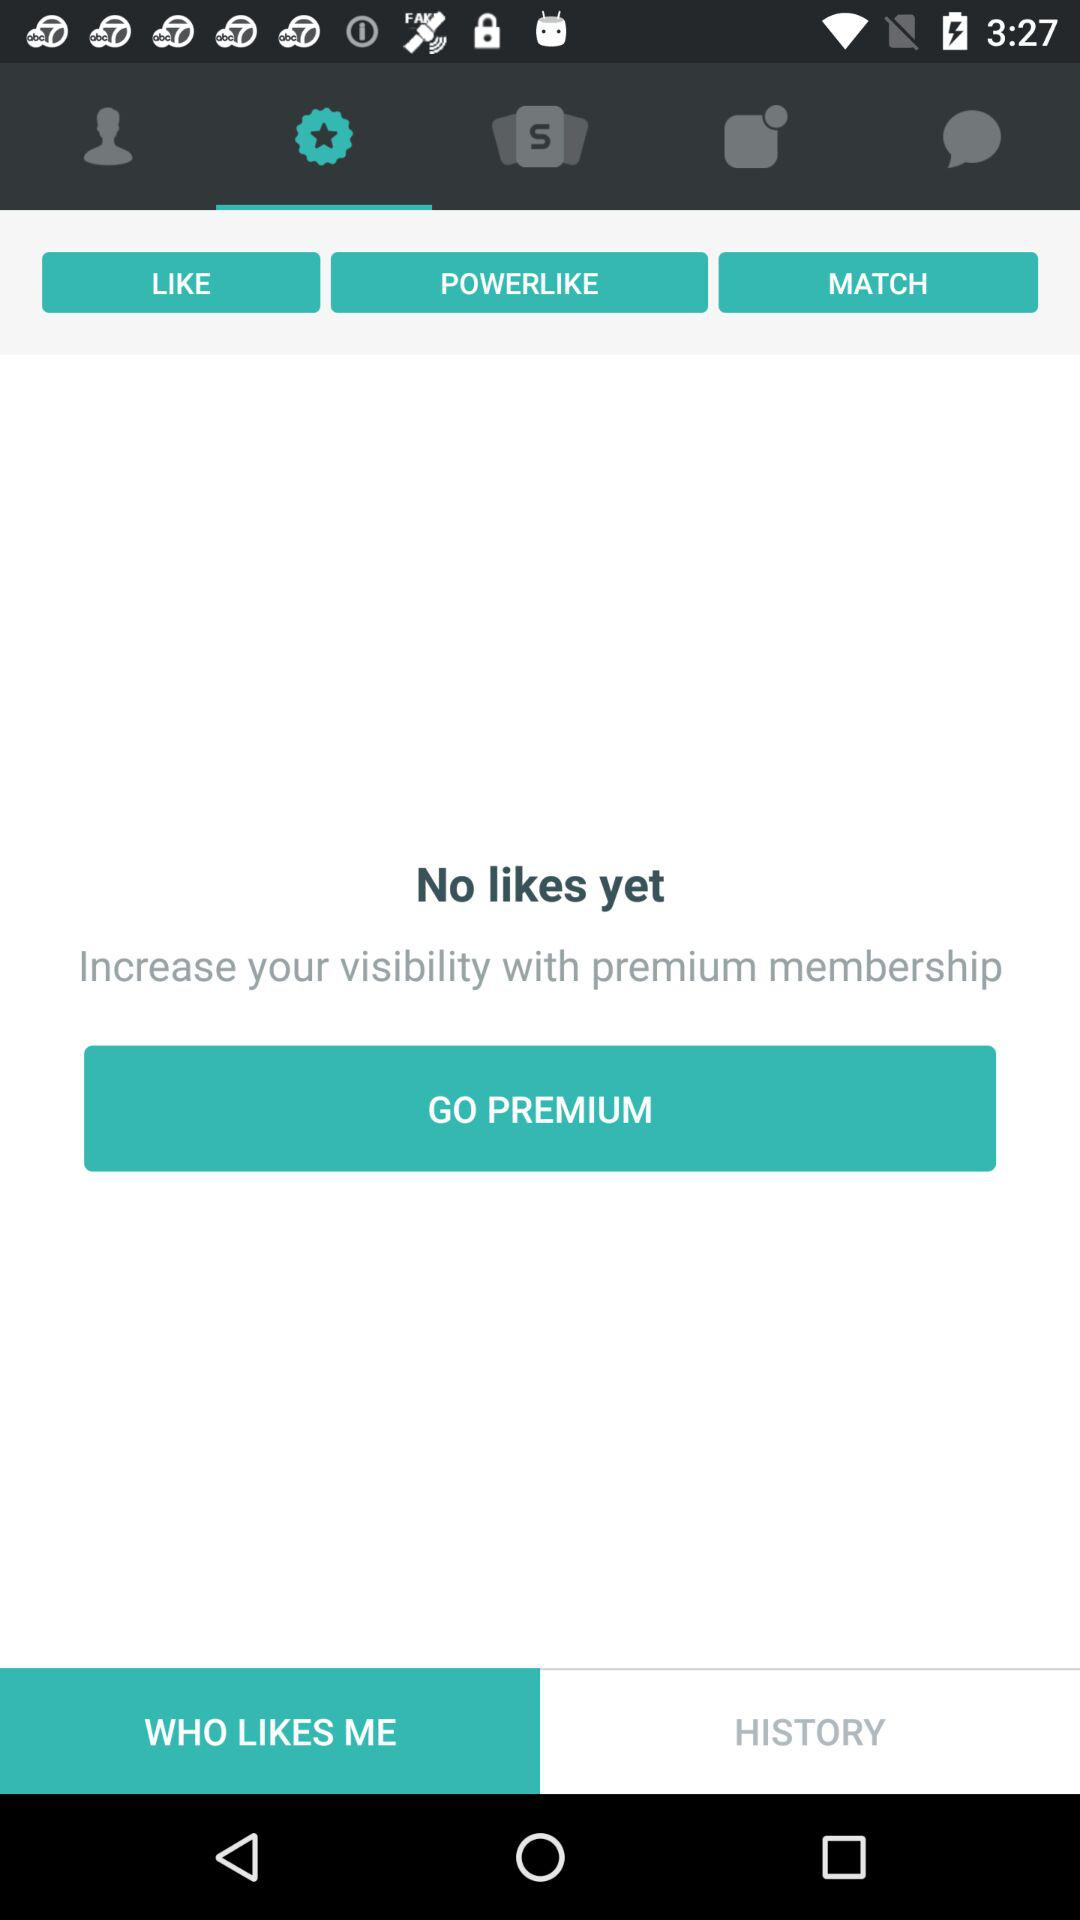How many likes are there? There are no likes. 